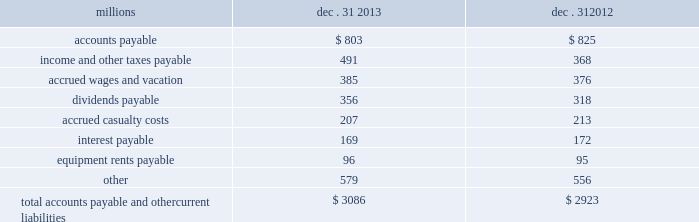The analysis of our depreciation studies .
Changes in the estimated service lives of our assets and their related depreciation rates are implemented prospectively .
Under group depreciation , the historical cost ( net of salvage ) of depreciable property that is retired or replaced in the ordinary course of business is charged to accumulated depreciation and no gain or loss is recognized .
The historical cost of certain track assets is estimated using ( i ) inflation indices published by the bureau of labor statistics and ( ii ) the estimated useful lives of the assets as determined by our depreciation studies .
The indices were selected because they closely correlate with the major costs of the properties comprising the applicable track asset classes .
Because of the number of estimates inherent in the depreciation and retirement processes and because it is impossible to precisely estimate each of these variables until a group of property is completely retired , we continually monitor the estimated service lives of our assets and the accumulated depreciation associated with each asset class to ensure our depreciation rates are appropriate .
In addition , we determine if the recorded amount of accumulated depreciation is deficient ( or in excess ) of the amount indicated by our depreciation studies .
Any deficiency ( or excess ) is amortized as a component of depreciation expense over the remaining service lives of the applicable classes of assets .
For retirements of depreciable railroad properties that do not occur in the normal course of business , a gain or loss may be recognized if the retirement meets each of the following three conditions : ( i ) is unusual , ( ii ) is material in amount , and ( iii ) varies significantly from the retirement profile identified through our depreciation studies .
A gain or loss is recognized in other income when we sell land or dispose of assets that are not part of our railroad operations .
When we purchase an asset , we capitalize all costs necessary to make the asset ready for its intended use .
However , many of our assets are self-constructed .
A large portion of our capital expenditures is for replacement of existing track assets and other road properties , which is typically performed by our employees , and for track line expansion and other capacity projects .
Costs that are directly attributable to capital projects ( including overhead costs ) are capitalized .
Direct costs that are capitalized as part of self- constructed assets include material , labor , and work equipment .
Indirect costs are capitalized if they clearly relate to the construction of the asset .
General and administrative expenditures are expensed as incurred .
Normal repairs and maintenance are also expensed as incurred , while costs incurred that extend the useful life of an asset , improve the safety of our operations or improve operating efficiency are capitalized .
These costs are allocated using appropriate statistical bases .
Total expense for repairs and maintenance incurred was $ 2.3 billion for 2013 , $ 2.1 billion for 2012 , and $ 2.2 billion for 2011 .
Assets held under capital leases are recorded at the lower of the net present value of the minimum lease payments or the fair value of the leased asset at the inception of the lease .
Amortization expense is computed using the straight-line method over the shorter of the estimated useful lives of the assets or the period of the related lease .
12 .
Accounts payable and other current liabilities dec .
31 , dec .
31 , millions 2013 2012 .

What was the percentage change in the total accounts payable and other current liabilities? 
Computations: ((3086 - 2923) / 2923)
Answer: 0.05576. The analysis of our depreciation studies .
Changes in the estimated service lives of our assets and their related depreciation rates are implemented prospectively .
Under group depreciation , the historical cost ( net of salvage ) of depreciable property that is retired or replaced in the ordinary course of business is charged to accumulated depreciation and no gain or loss is recognized .
The historical cost of certain track assets is estimated using ( i ) inflation indices published by the bureau of labor statistics and ( ii ) the estimated useful lives of the assets as determined by our depreciation studies .
The indices were selected because they closely correlate with the major costs of the properties comprising the applicable track asset classes .
Because of the number of estimates inherent in the depreciation and retirement processes and because it is impossible to precisely estimate each of these variables until a group of property is completely retired , we continually monitor the estimated service lives of our assets and the accumulated depreciation associated with each asset class to ensure our depreciation rates are appropriate .
In addition , we determine if the recorded amount of accumulated depreciation is deficient ( or in excess ) of the amount indicated by our depreciation studies .
Any deficiency ( or excess ) is amortized as a component of depreciation expense over the remaining service lives of the applicable classes of assets .
For retirements of depreciable railroad properties that do not occur in the normal course of business , a gain or loss may be recognized if the retirement meets each of the following three conditions : ( i ) is unusual , ( ii ) is material in amount , and ( iii ) varies significantly from the retirement profile identified through our depreciation studies .
A gain or loss is recognized in other income when we sell land or dispose of assets that are not part of our railroad operations .
When we purchase an asset , we capitalize all costs necessary to make the asset ready for its intended use .
However , many of our assets are self-constructed .
A large portion of our capital expenditures is for replacement of existing track assets and other road properties , which is typically performed by our employees , and for track line expansion and other capacity projects .
Costs that are directly attributable to capital projects ( including overhead costs ) are capitalized .
Direct costs that are capitalized as part of self- constructed assets include material , labor , and work equipment .
Indirect costs are capitalized if they clearly relate to the construction of the asset .
General and administrative expenditures are expensed as incurred .
Normal repairs and maintenance are also expensed as incurred , while costs incurred that extend the useful life of an asset , improve the safety of our operations or improve operating efficiency are capitalized .
These costs are allocated using appropriate statistical bases .
Total expense for repairs and maintenance incurred was $ 2.3 billion for 2013 , $ 2.1 billion for 2012 , and $ 2.2 billion for 2011 .
Assets held under capital leases are recorded at the lower of the net present value of the minimum lease payments or the fair value of the leased asset at the inception of the lease .
Amortization expense is computed using the straight-line method over the shorter of the estimated useful lives of the assets or the period of the related lease .
12 .
Accounts payable and other current liabilities dec .
31 , dec .
31 , millions 2013 2012 .

What was the percentage change in total expense for repairs and maintenance from 2012 to 2013? 
Computations: ((2.3 - 2.1) / 2.1)
Answer: 0.09524. 